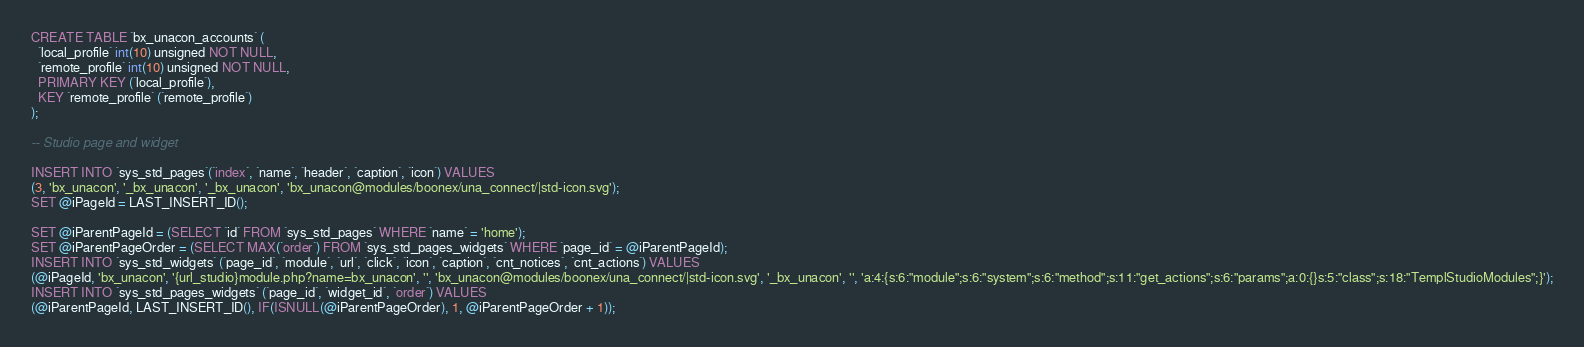<code> <loc_0><loc_0><loc_500><loc_500><_SQL_>
CREATE TABLE `bx_unacon_accounts` (
  `local_profile` int(10) unsigned NOT NULL,
  `remote_profile` int(10) unsigned NOT NULL,
  PRIMARY KEY (`local_profile`),
  KEY `remote_profile` (`remote_profile`)
);

-- Studio page and widget

INSERT INTO `sys_std_pages`(`index`, `name`, `header`, `caption`, `icon`) VALUES
(3, 'bx_unacon', '_bx_unacon', '_bx_unacon', 'bx_unacon@modules/boonex/una_connect/|std-icon.svg');
SET @iPageId = LAST_INSERT_ID();

SET @iParentPageId = (SELECT `id` FROM `sys_std_pages` WHERE `name` = 'home');
SET @iParentPageOrder = (SELECT MAX(`order`) FROM `sys_std_pages_widgets` WHERE `page_id` = @iParentPageId);
INSERT INTO `sys_std_widgets` (`page_id`, `module`, `url`, `click`, `icon`, `caption`, `cnt_notices`, `cnt_actions`) VALUES
(@iPageId, 'bx_unacon', '{url_studio}module.php?name=bx_unacon', '', 'bx_unacon@modules/boonex/una_connect/|std-icon.svg', '_bx_unacon', '', 'a:4:{s:6:"module";s:6:"system";s:6:"method";s:11:"get_actions";s:6:"params";a:0:{}s:5:"class";s:18:"TemplStudioModules";}');
INSERT INTO `sys_std_pages_widgets` (`page_id`, `widget_id`, `order`) VALUES
(@iParentPageId, LAST_INSERT_ID(), IF(ISNULL(@iParentPageOrder), 1, @iParentPageOrder + 1));

</code> 